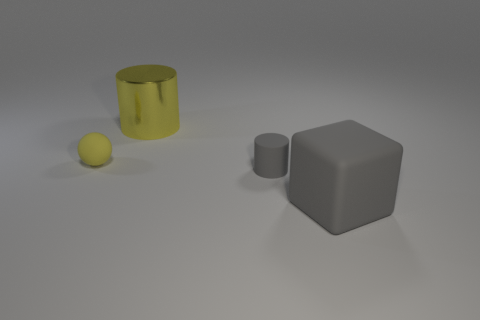Add 1 gray things. How many objects exist? 5 Subtract all blocks. How many objects are left? 3 Add 3 small yellow spheres. How many small yellow spheres are left? 4 Add 2 gray rubber blocks. How many gray rubber blocks exist? 3 Subtract 0 red balls. How many objects are left? 4 Subtract all metal cylinders. Subtract all small cyan things. How many objects are left? 3 